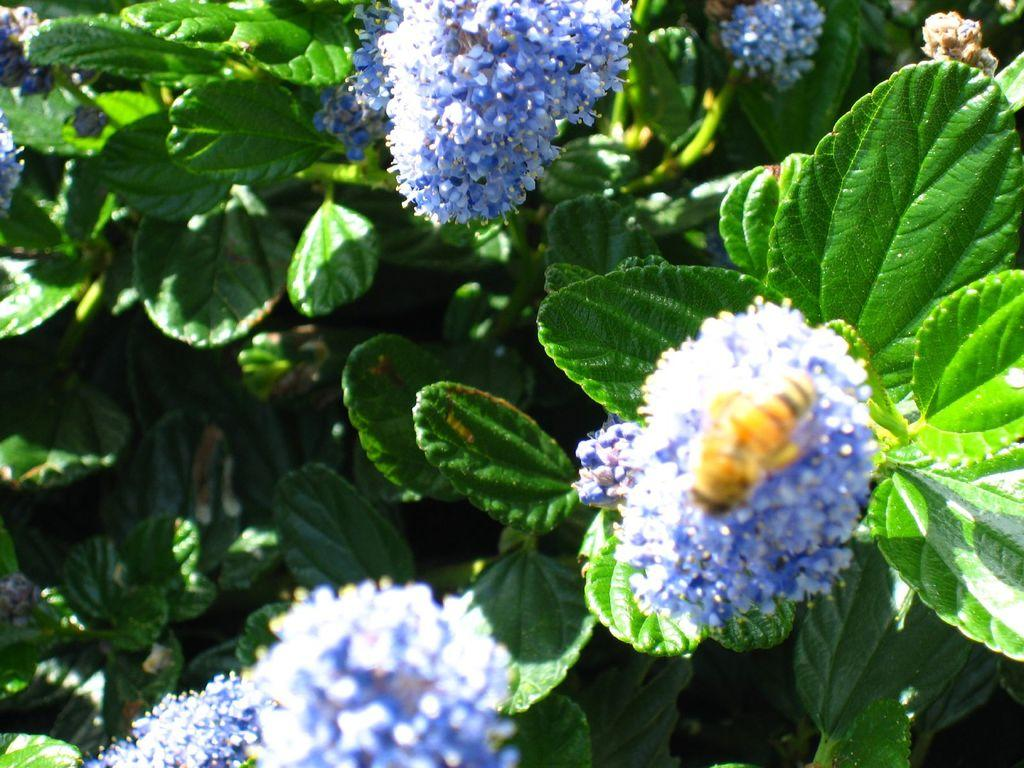What color are the flowers in the image? The flowers in the image are blue. What are the flowers growing on? The flowers are on plants. What type of sound can be heard coming from the flowers in the image? There is no sound coming from the flowers in the image, as flowers do not produce sound. 